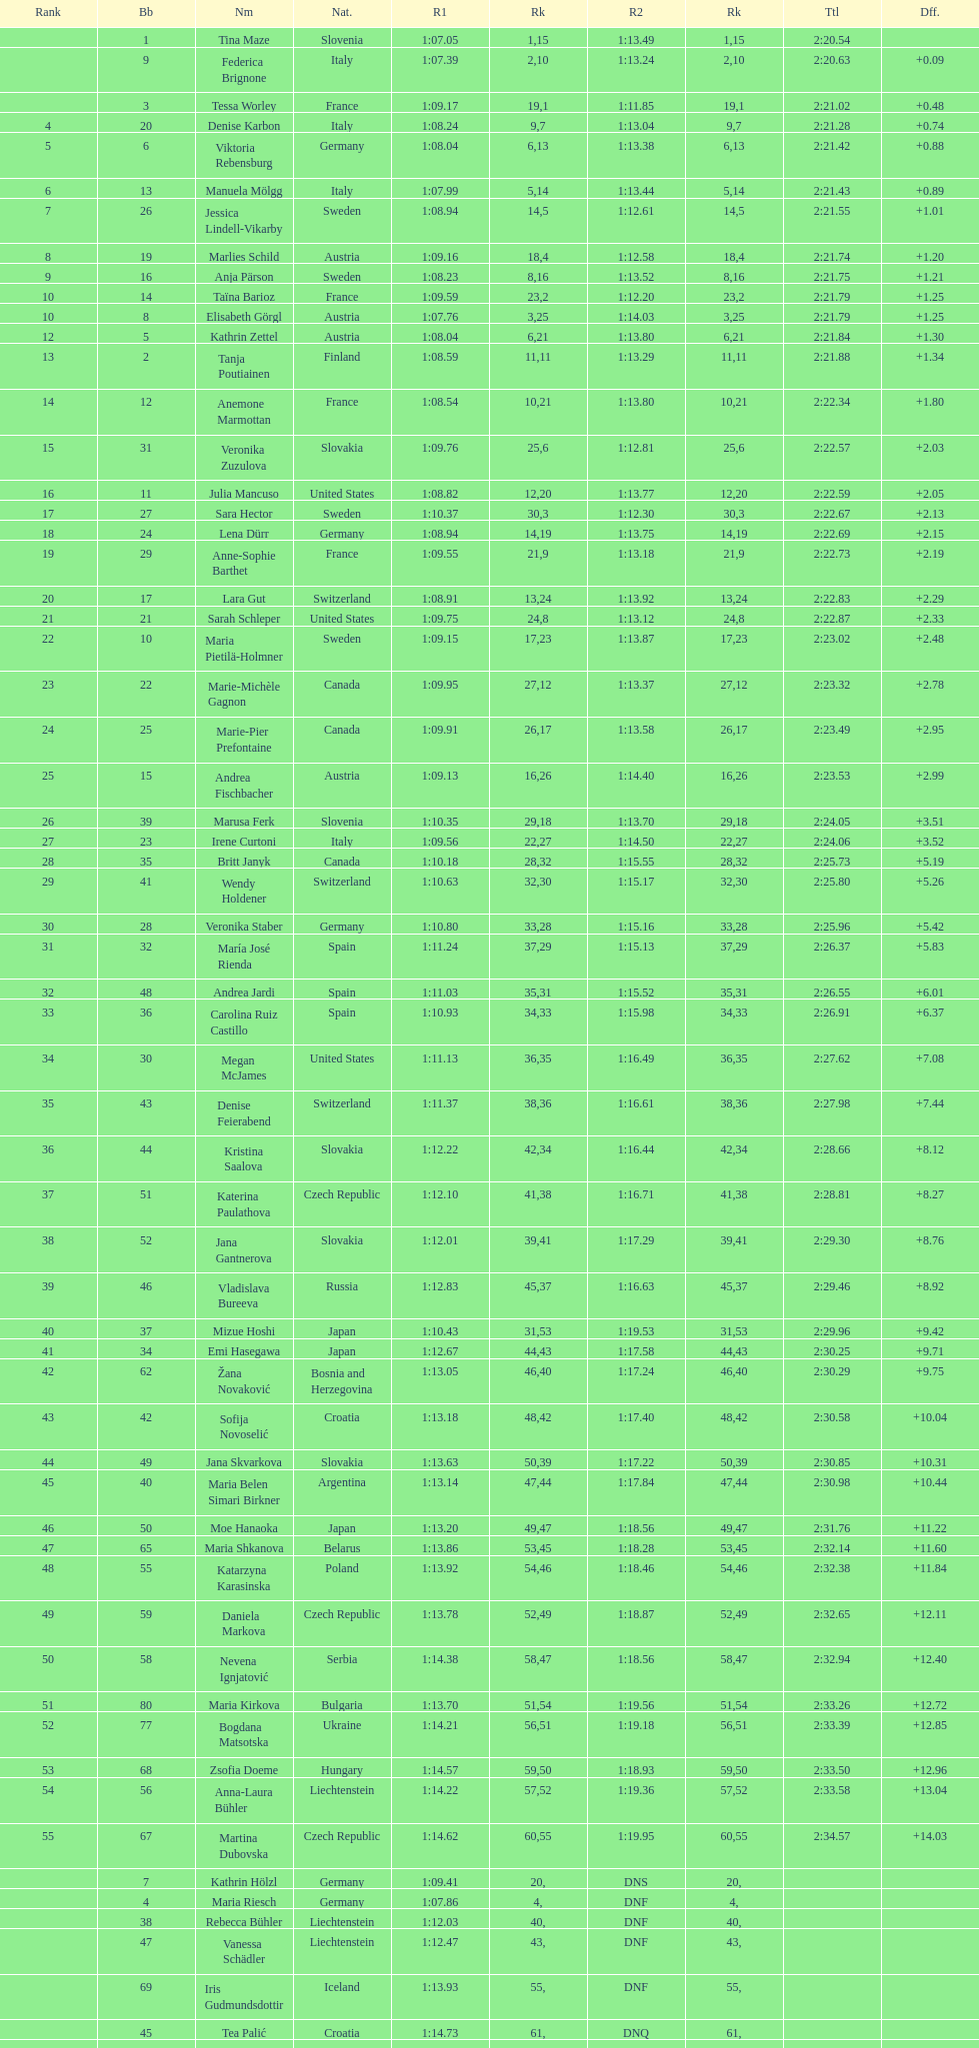What is the name before anja parson? Marlies Schild. 